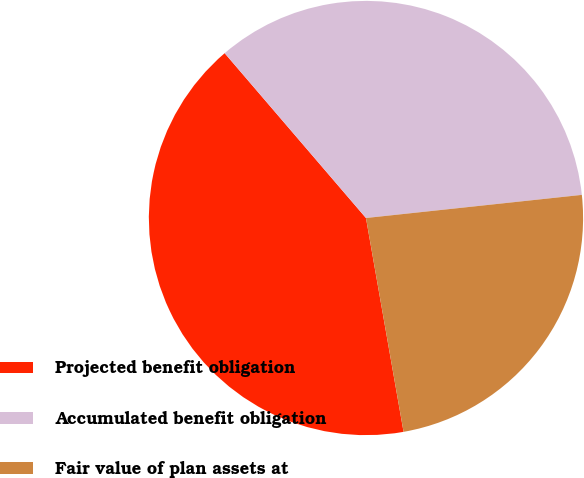Convert chart. <chart><loc_0><loc_0><loc_500><loc_500><pie_chart><fcel>Projected benefit obligation<fcel>Accumulated benefit obligation<fcel>Fair value of plan assets at<nl><fcel>41.49%<fcel>34.58%<fcel>23.93%<nl></chart> 